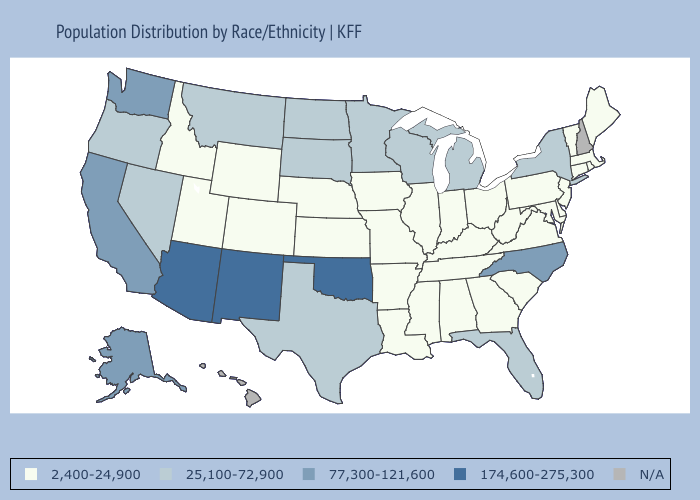Does New York have the lowest value in the Northeast?
Quick response, please. No. How many symbols are there in the legend?
Be succinct. 5. Does Florida have the lowest value in the South?
Answer briefly. No. What is the value of Rhode Island?
Answer briefly. 2,400-24,900. What is the value of Wyoming?
Short answer required. 2,400-24,900. Which states hav the highest value in the MidWest?
Concise answer only. Michigan, Minnesota, North Dakota, South Dakota, Wisconsin. What is the value of Maine?
Write a very short answer. 2,400-24,900. What is the value of New Jersey?
Keep it brief. 2,400-24,900. What is the value of Texas?
Write a very short answer. 25,100-72,900. Does Oklahoma have the highest value in the South?
Concise answer only. Yes. Does Washington have the lowest value in the West?
Concise answer only. No. Is the legend a continuous bar?
Quick response, please. No. What is the value of Mississippi?
Give a very brief answer. 2,400-24,900. Name the states that have a value in the range 25,100-72,900?
Short answer required. Florida, Michigan, Minnesota, Montana, Nevada, New York, North Dakota, Oregon, South Dakota, Texas, Wisconsin. 